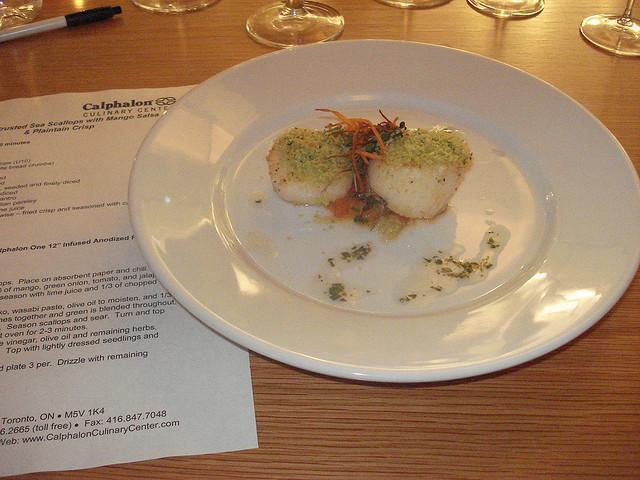How many wine glasses are there?
Give a very brief answer. 2. 